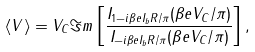Convert formula to latex. <formula><loc_0><loc_0><loc_500><loc_500>\langle V \rangle = V _ { C } \Im m \left [ \frac { I _ { 1 - i \beta e I _ { b } R / \pi } ( \beta e V _ { C } / \pi ) } { I _ { - i \beta e I _ { b } R / \pi } ( \beta e V _ { C } / \pi ) } \right ] ,</formula> 